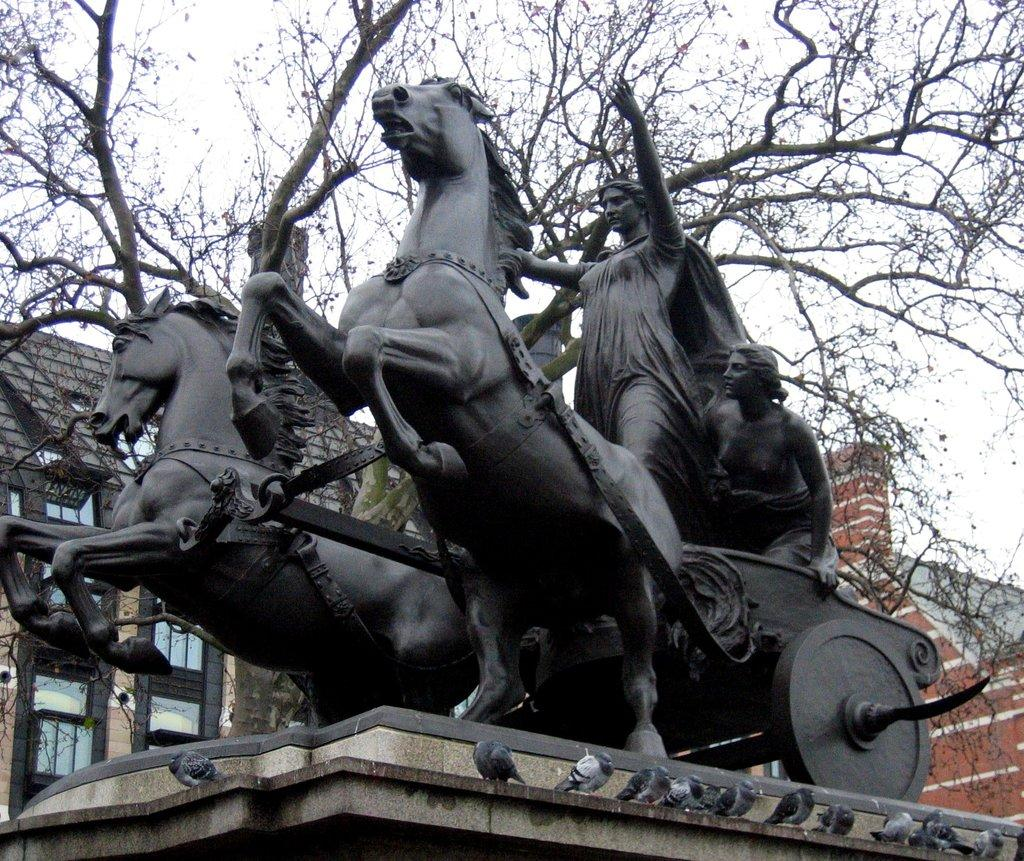What is the main subject of the image? There is a statue of two women riding a horse in the image. What can be seen in the background of the image? Buildings, trees, and the sky are visible in the background of the image. What type of seed is being planted by the horse in the image? There is no seed or planting activity depicted in the image; it features a statue of two women riding a horse. What act are the women performing on the horse in the image? The image is a statue, so the women are not performing any act; they are depicted in a static pose. 